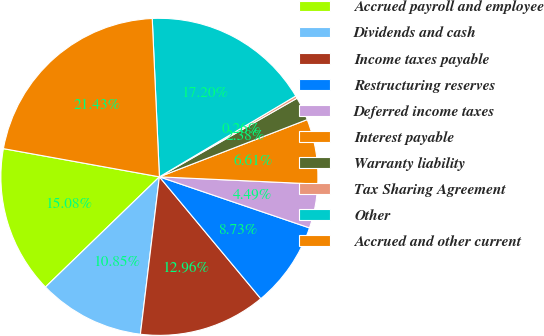Convert chart to OTSL. <chart><loc_0><loc_0><loc_500><loc_500><pie_chart><fcel>Accrued payroll and employee<fcel>Dividends and cash<fcel>Income taxes payable<fcel>Restructuring reserves<fcel>Deferred income taxes<fcel>Interest payable<fcel>Warranty liability<fcel>Tax Sharing Agreement<fcel>Other<fcel>Accrued and other current<nl><fcel>15.08%<fcel>10.85%<fcel>12.96%<fcel>8.73%<fcel>4.49%<fcel>6.61%<fcel>2.38%<fcel>0.26%<fcel>17.2%<fcel>21.43%<nl></chart> 